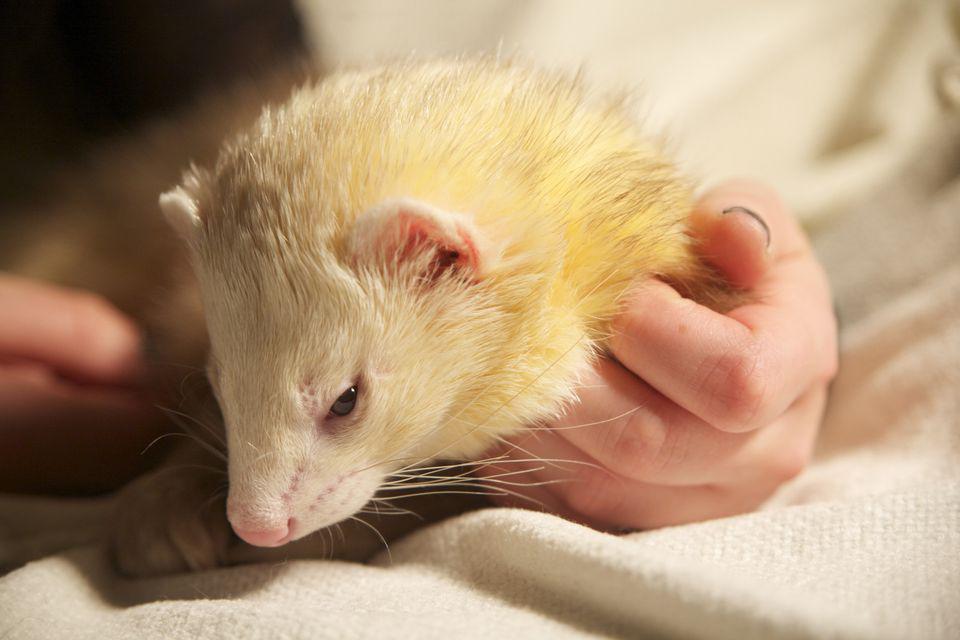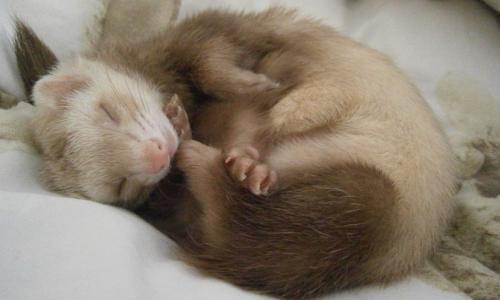The first image is the image on the left, the second image is the image on the right. Analyze the images presented: Is the assertion "The right image contains exactly two ferrets." valid? Answer yes or no. No. The first image is the image on the left, the second image is the image on the right. Assess this claim about the two images: "There are more animals in the image on the right.". Correct or not? Answer yes or no. No. 